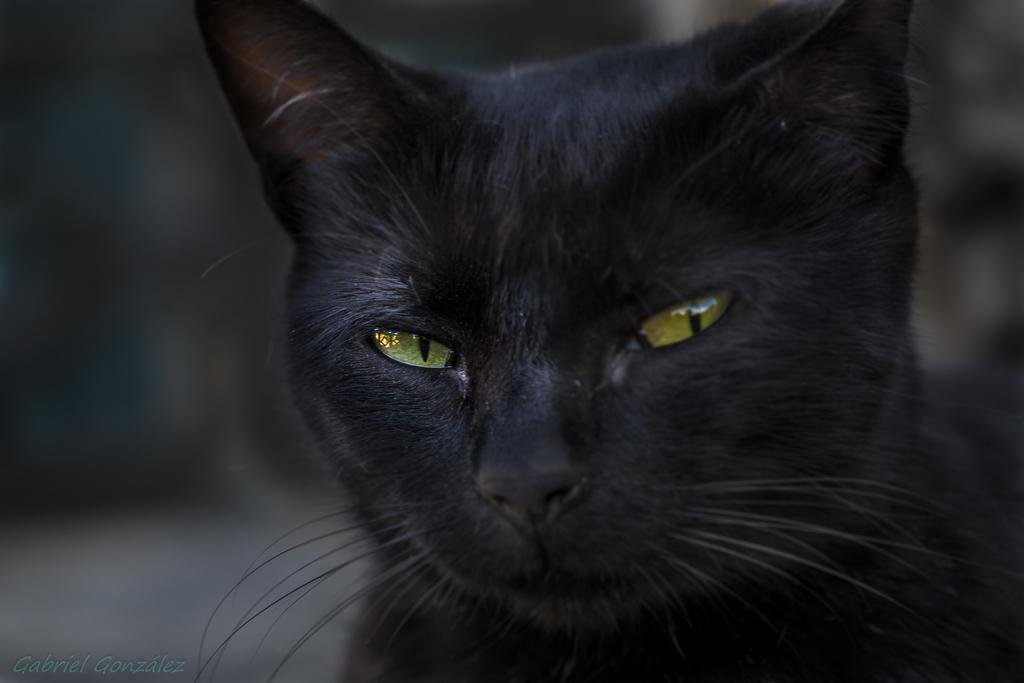What type of animal is in the image? There is a black cat in the image. What color is the background of the image? The background appears to be blue. Is there any text or logo visible in the image? Yes, there is a watermark in the bottom left corner of the image. Can you hear the cat meowing in the image? The image is a still photograph, so it does not contain any sound. Therefore, we cannot hear the cat meowing in the image. 